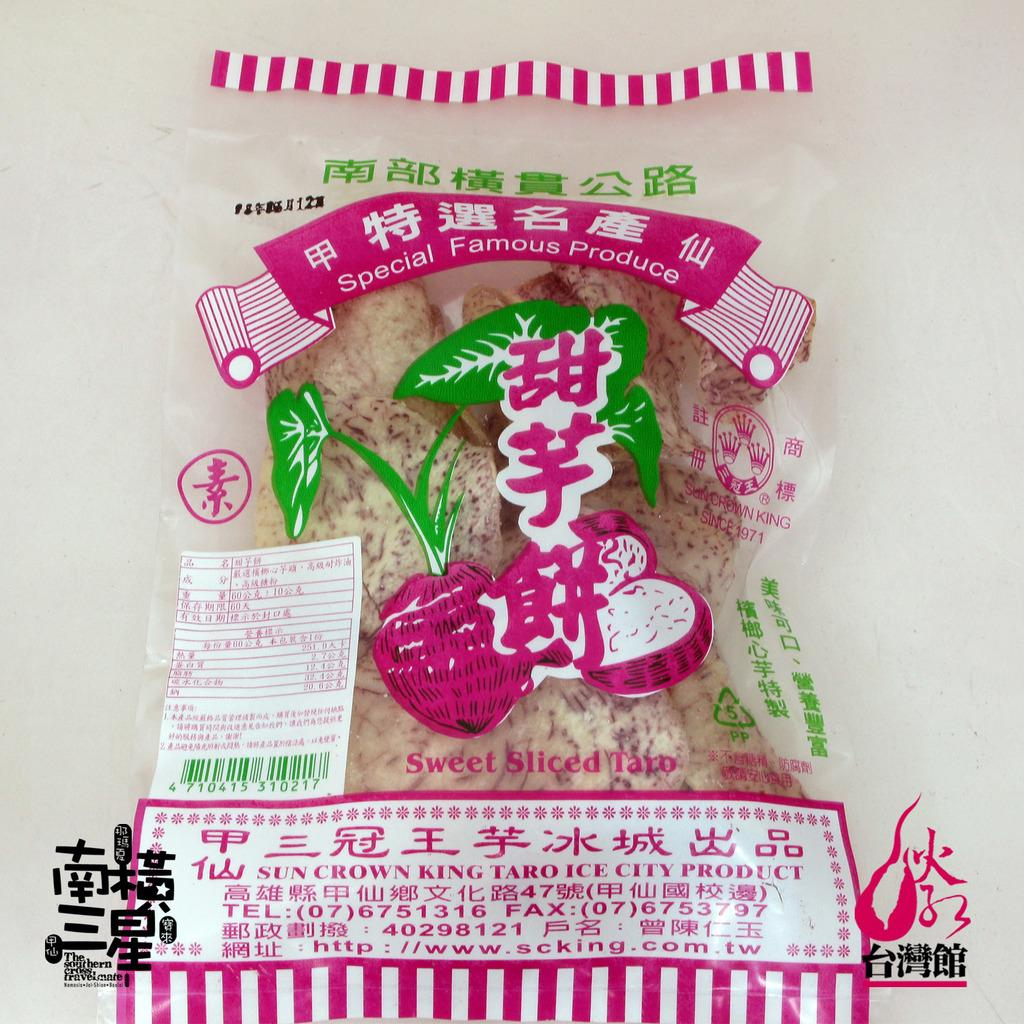<image>
Relay a brief, clear account of the picture shown. A bag of food is produced by Sun Crown King. 